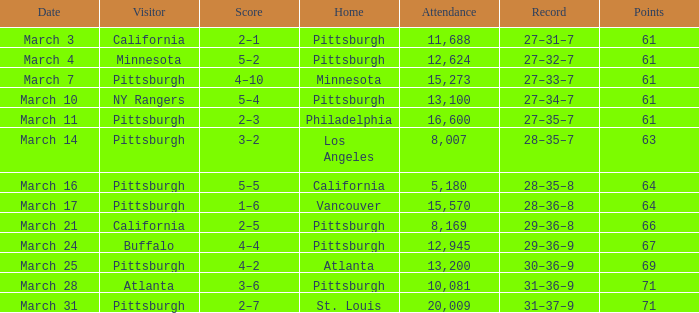What is the Score of the Pittsburgh Home game on March 3 with 61 Points? 2–1. 